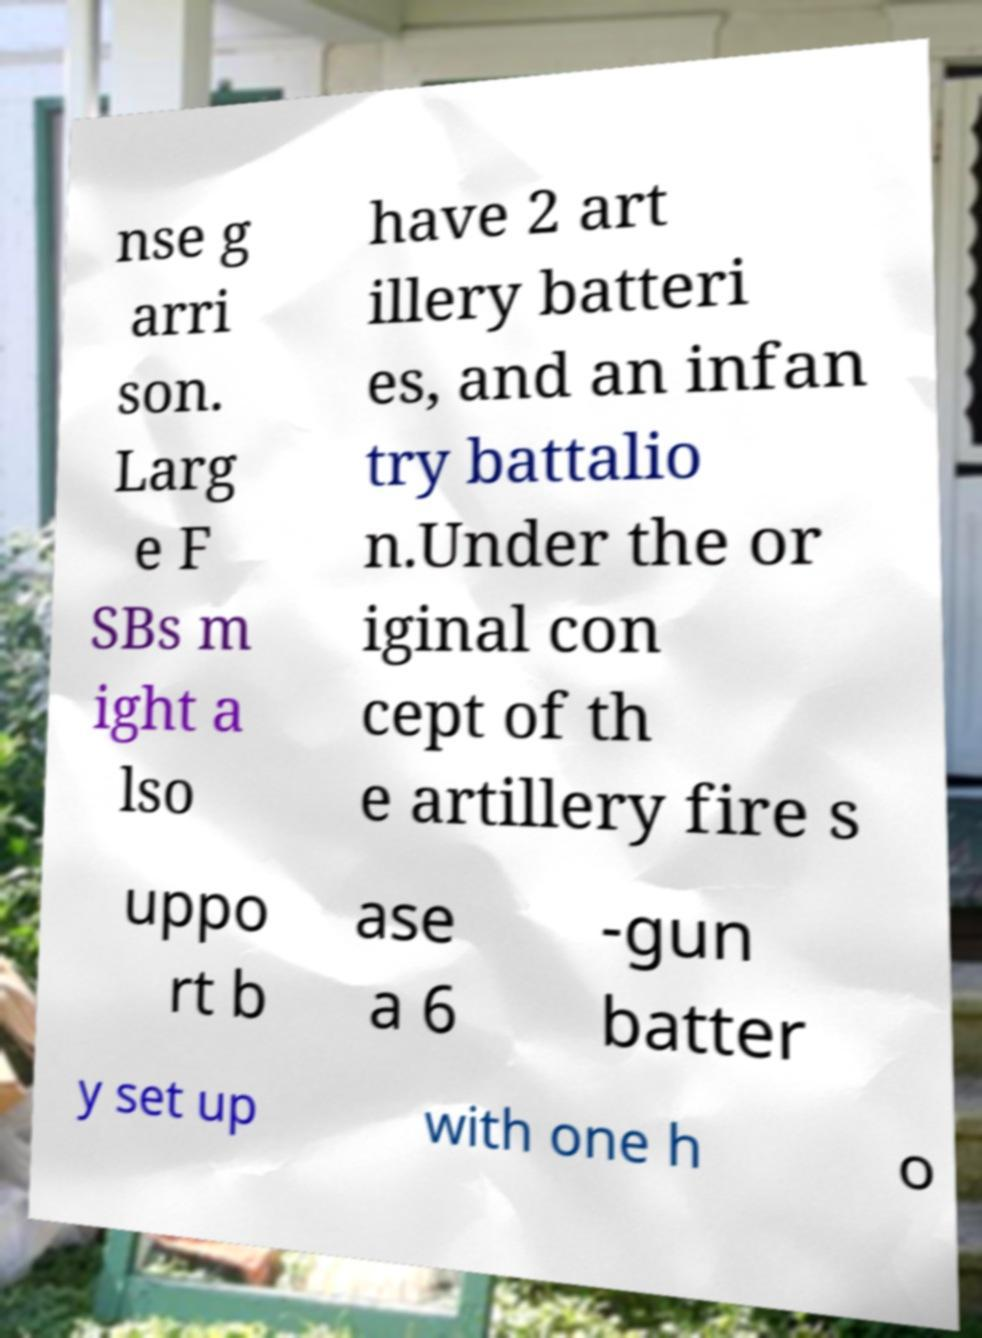There's text embedded in this image that I need extracted. Can you transcribe it verbatim? nse g arri son. Larg e F SBs m ight a lso have 2 art illery batteri es, and an infan try battalio n.Under the or iginal con cept of th e artillery fire s uppo rt b ase a 6 -gun batter y set up with one h o 